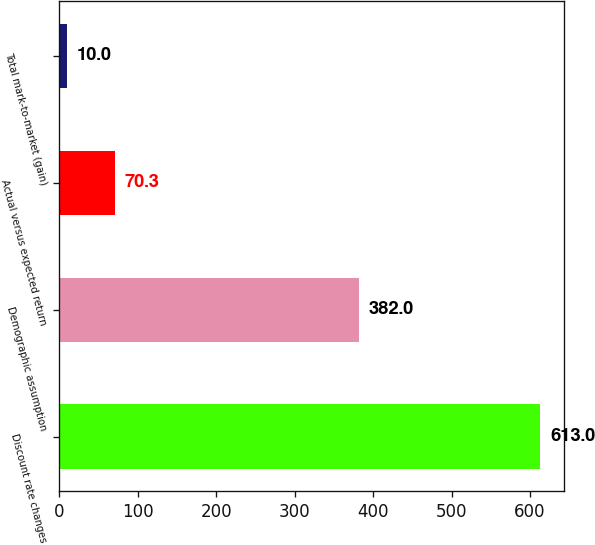<chart> <loc_0><loc_0><loc_500><loc_500><bar_chart><fcel>Discount rate changes<fcel>Demographic assumption<fcel>Actual versus expected return<fcel>Total mark-to-market (gain)<nl><fcel>613<fcel>382<fcel>70.3<fcel>10<nl></chart> 